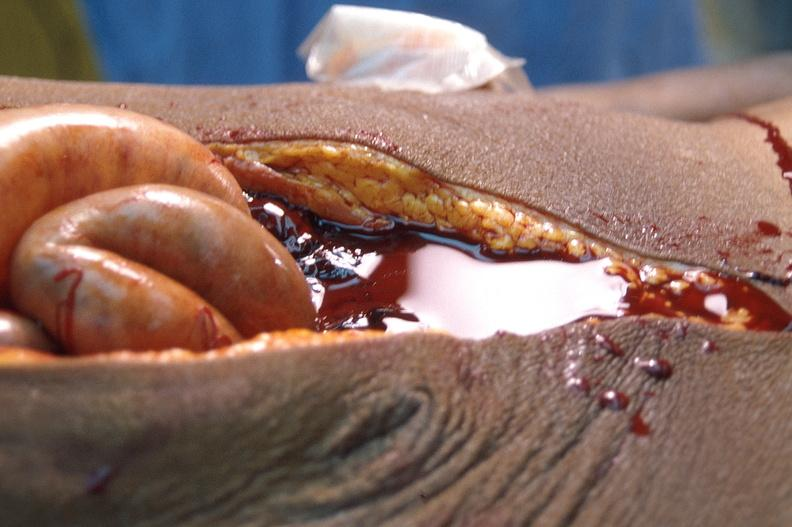what is present?
Answer the question using a single word or phrase. Abdomen 